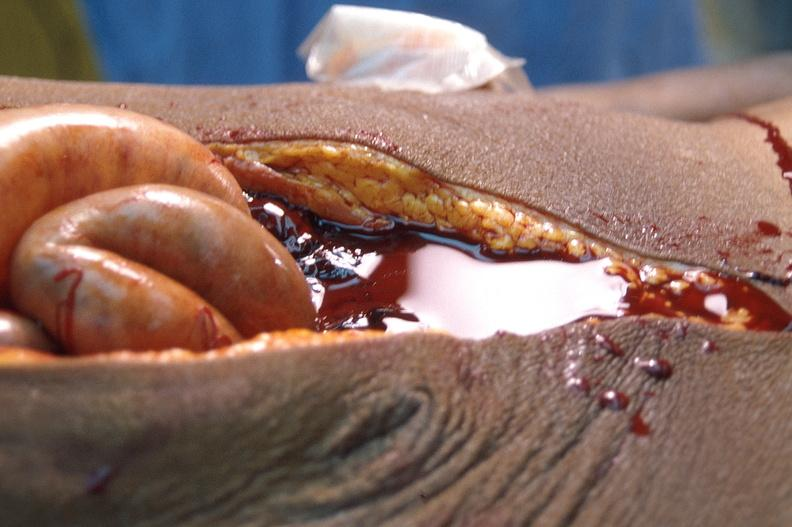what is present?
Answer the question using a single word or phrase. Abdomen 